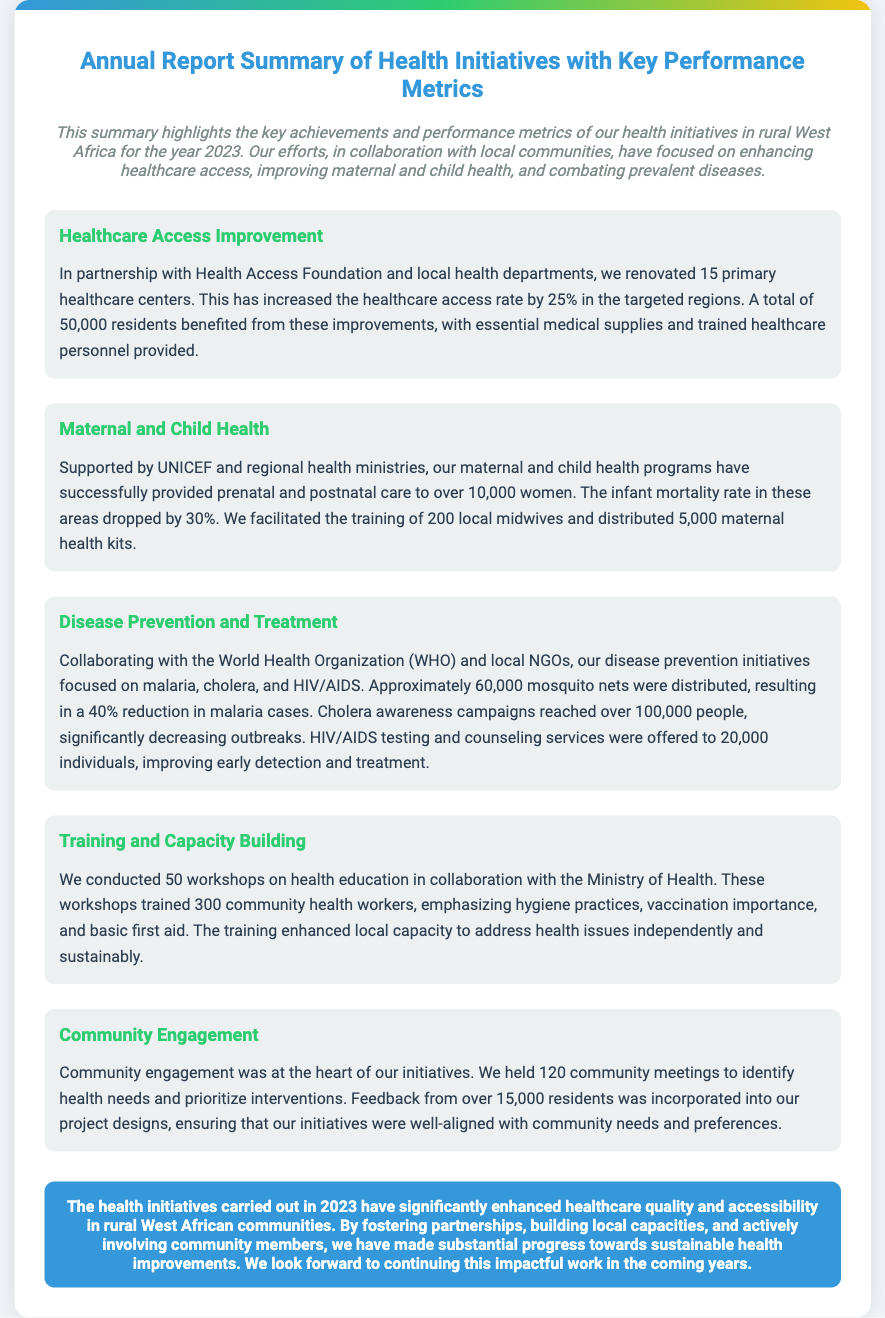what is the increase in healthcare access rate? The increase in healthcare access rate is mentioned as a percentage in the healthcare access improvement section, which indicates a 25% increase.
Answer: 25% how many primary healthcare centers were renovated? The document states that 15 primary healthcare centers were renovated in collaboration with the Health Access Foundation and local health departments.
Answer: 15 what was the drop in infant mortality rate? The maternal and child health section indicates that the infant mortality rate dropped by a specific percentage. The document cites this percentage as 30%.
Answer: 30% how many local midwives were trained? The maternal and child health program section notes that 200 local midwives were trained to support maternal and child health initiatives.
Answer: 200 how many mosquito nets were distributed? The disease prevention initiatives section mentions the distribution of mosquito nets, with the document specifying that approximately 60,000 were distributed.
Answer: 60,000 how many workshops were conducted on health education? The training and capacity building section reveals that 50 workshops on health education were conducted in collaboration with the Ministry of Health.
Answer: 50 how many community meetings were held? The community engagement section indicates that 120 community meetings were held to identify health needs and prioritize interventions.
Answer: 120 who supported the maternal and child health programs? The document identifies UNICEF and regional health ministries as the supporters of the maternal and child health programs.
Answer: UNICEF what is the main focus of the health initiatives? The introduction highlights the main focus of the health initiatives, which is enhancing healthcare access and improving maternal and child health.
Answer: healthcare access and maternal and child health 